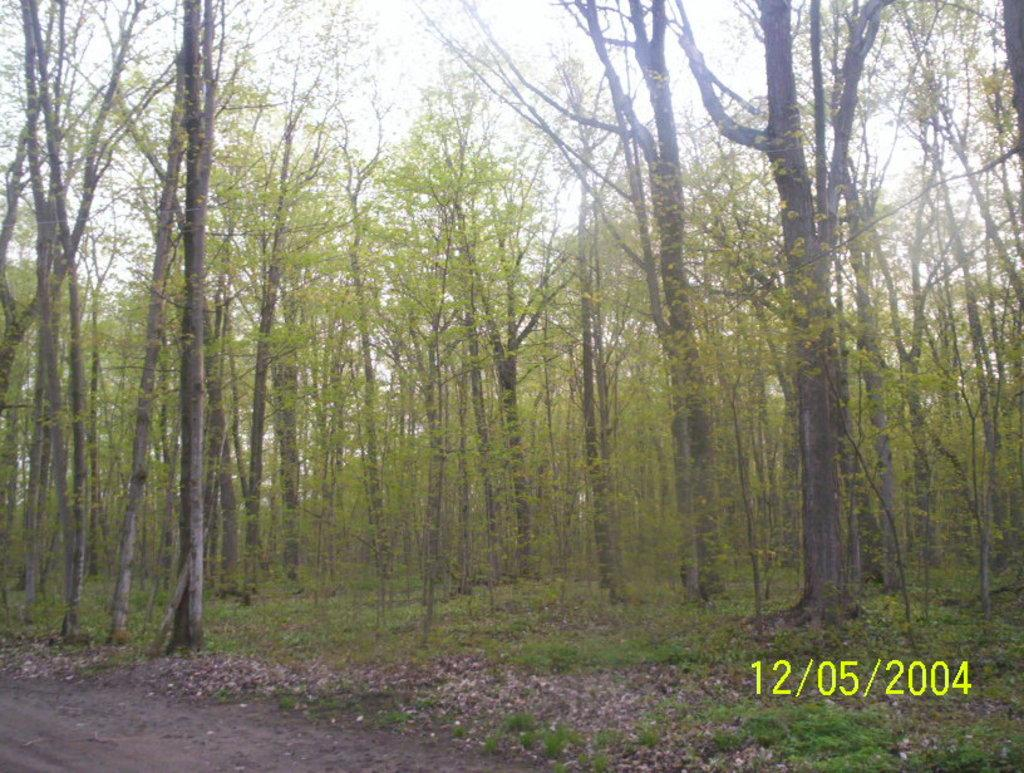What type of vegetation can be seen in the image? There is a group of trees in the image. What surface can people walk on in the image? There is a walkway in the image. What type of ground cover is present in the image? Grass is present in the image. What additional feature can be seen on the ground in the image? Dry leaves are visible in the image. What is written or displayed at the bottom of the image? There is text at the bottom of the image. What is visible in the sky in the image? The sky is visible at the top of the image. What type of appliance can be seen causing destruction in the image? There is no appliance or destruction present in the image. What type of wall is visible in the image? There is no wall present in the image. 